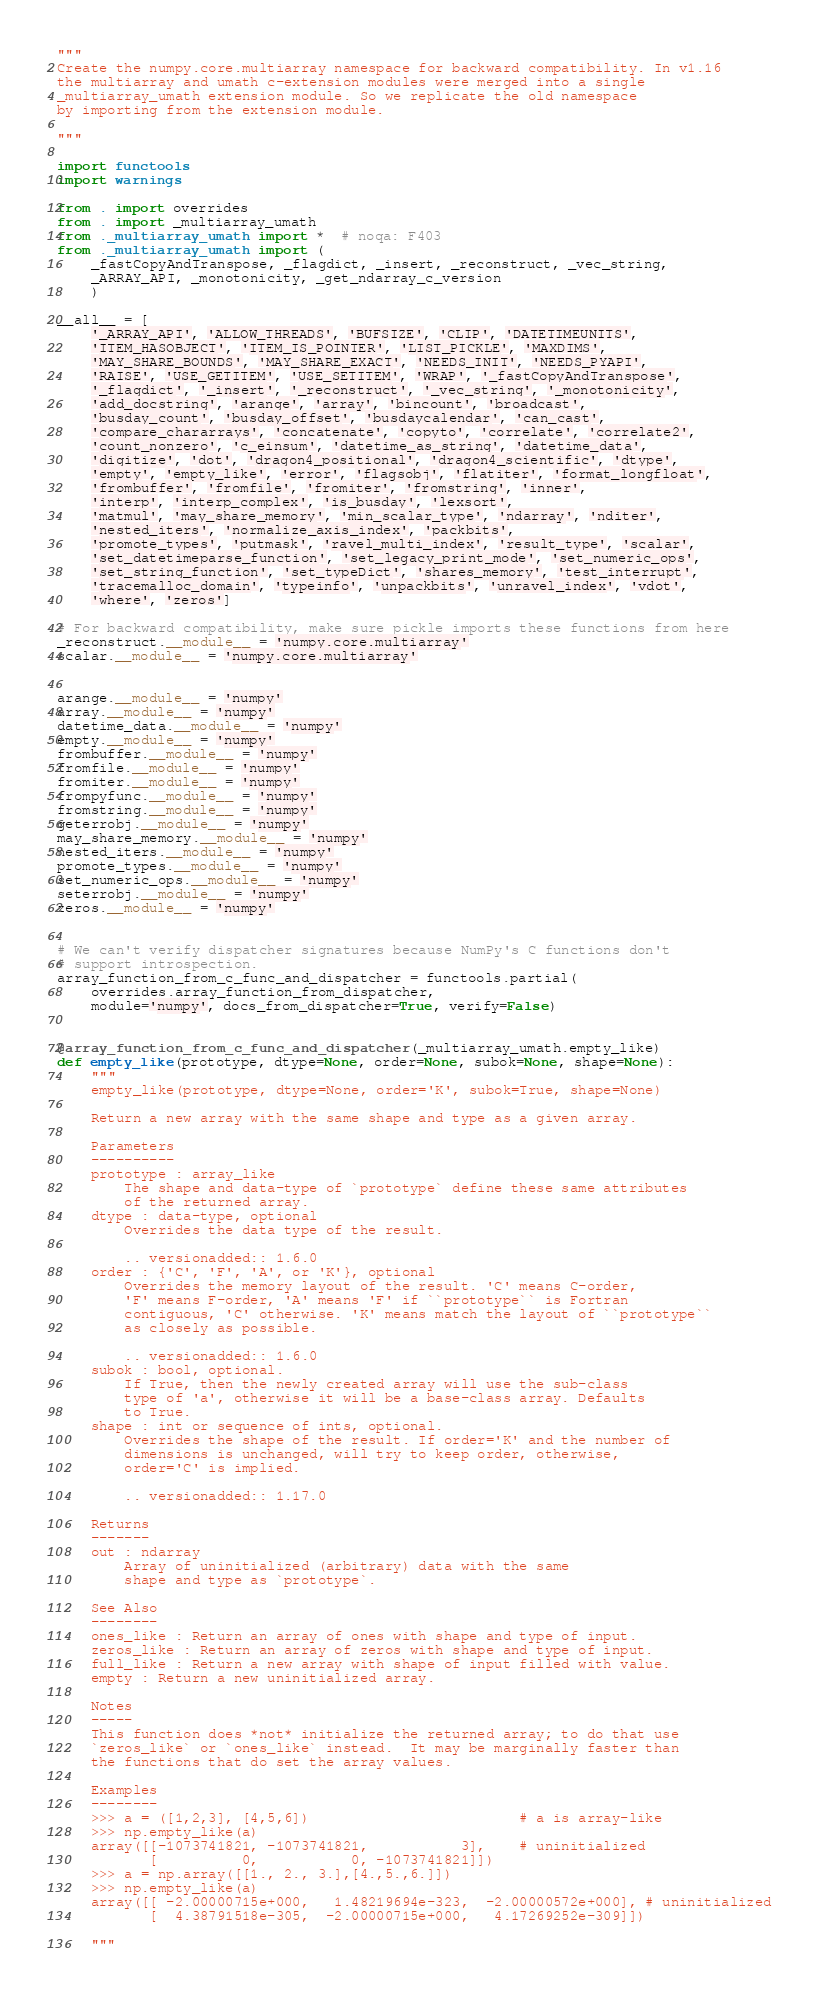Convert code to text. <code><loc_0><loc_0><loc_500><loc_500><_Python_>"""
Create the numpy.core.multiarray namespace for backward compatibility. In v1.16
the multiarray and umath c-extension modules were merged into a single
_multiarray_umath extension module. So we replicate the old namespace
by importing from the extension module.

"""

import functools
import warnings

from . import overrides
from . import _multiarray_umath
from ._multiarray_umath import *  # noqa: F403
from ._multiarray_umath import (
    _fastCopyAndTranspose, _flagdict, _insert, _reconstruct, _vec_string,
    _ARRAY_API, _monotonicity, _get_ndarray_c_version
    )

__all__ = [
    '_ARRAY_API', 'ALLOW_THREADS', 'BUFSIZE', 'CLIP', 'DATETIMEUNITS',
    'ITEM_HASOBJECT', 'ITEM_IS_POINTER', 'LIST_PICKLE', 'MAXDIMS',
    'MAY_SHARE_BOUNDS', 'MAY_SHARE_EXACT', 'NEEDS_INIT', 'NEEDS_PYAPI',
    'RAISE', 'USE_GETITEM', 'USE_SETITEM', 'WRAP', '_fastCopyAndTranspose',
    '_flagdict', '_insert', '_reconstruct', '_vec_string', '_monotonicity',
    'add_docstring', 'arange', 'array', 'bincount', 'broadcast',
    'busday_count', 'busday_offset', 'busdaycalendar', 'can_cast',
    'compare_chararrays', 'concatenate', 'copyto', 'correlate', 'correlate2',
    'count_nonzero', 'c_einsum', 'datetime_as_string', 'datetime_data',
    'digitize', 'dot', 'dragon4_positional', 'dragon4_scientific', 'dtype',
    'empty', 'empty_like', 'error', 'flagsobj', 'flatiter', 'format_longfloat',
    'frombuffer', 'fromfile', 'fromiter', 'fromstring', 'inner',
    'interp', 'interp_complex', 'is_busday', 'lexsort',
    'matmul', 'may_share_memory', 'min_scalar_type', 'ndarray', 'nditer',
    'nested_iters', 'normalize_axis_index', 'packbits',
    'promote_types', 'putmask', 'ravel_multi_index', 'result_type', 'scalar',
    'set_datetimeparse_function', 'set_legacy_print_mode', 'set_numeric_ops',
    'set_string_function', 'set_typeDict', 'shares_memory', 'test_interrupt',
    'tracemalloc_domain', 'typeinfo', 'unpackbits', 'unravel_index', 'vdot',
    'where', 'zeros']

# For backward compatibility, make sure pickle imports these functions from here
_reconstruct.__module__ = 'numpy.core.multiarray'
scalar.__module__ = 'numpy.core.multiarray'


arange.__module__ = 'numpy'
array.__module__ = 'numpy'
datetime_data.__module__ = 'numpy'
empty.__module__ = 'numpy'
frombuffer.__module__ = 'numpy'
fromfile.__module__ = 'numpy'
fromiter.__module__ = 'numpy'
frompyfunc.__module__ = 'numpy'
fromstring.__module__ = 'numpy'
geterrobj.__module__ = 'numpy'
may_share_memory.__module__ = 'numpy'
nested_iters.__module__ = 'numpy'
promote_types.__module__ = 'numpy'
set_numeric_ops.__module__ = 'numpy'
seterrobj.__module__ = 'numpy'
zeros.__module__ = 'numpy'


# We can't verify dispatcher signatures because NumPy's C functions don't
# support introspection.
array_function_from_c_func_and_dispatcher = functools.partial(
    overrides.array_function_from_dispatcher,
    module='numpy', docs_from_dispatcher=True, verify=False)


@array_function_from_c_func_and_dispatcher(_multiarray_umath.empty_like)
def empty_like(prototype, dtype=None, order=None, subok=None, shape=None):
    """
    empty_like(prototype, dtype=None, order='K', subok=True, shape=None)

    Return a new array with the same shape and type as a given array.

    Parameters
    ----------
    prototype : array_like
        The shape and data-type of `prototype` define these same attributes
        of the returned array.
    dtype : data-type, optional
        Overrides the data type of the result.

        .. versionadded:: 1.6.0
    order : {'C', 'F', 'A', or 'K'}, optional
        Overrides the memory layout of the result. 'C' means C-order,
        'F' means F-order, 'A' means 'F' if ``prototype`` is Fortran
        contiguous, 'C' otherwise. 'K' means match the layout of ``prototype``
        as closely as possible.

        .. versionadded:: 1.6.0
    subok : bool, optional.
        If True, then the newly created array will use the sub-class
        type of 'a', otherwise it will be a base-class array. Defaults
        to True.
    shape : int or sequence of ints, optional.
        Overrides the shape of the result. If order='K' and the number of
        dimensions is unchanged, will try to keep order, otherwise,
        order='C' is implied.

        .. versionadded:: 1.17.0

    Returns
    -------
    out : ndarray
        Array of uninitialized (arbitrary) data with the same
        shape and type as `prototype`.

    See Also
    --------
    ones_like : Return an array of ones with shape and type of input.
    zeros_like : Return an array of zeros with shape and type of input.
    full_like : Return a new array with shape of input filled with value.
    empty : Return a new uninitialized array.

    Notes
    -----
    This function does *not* initialize the returned array; to do that use
    `zeros_like` or `ones_like` instead.  It may be marginally faster than
    the functions that do set the array values.

    Examples
    --------
    >>> a = ([1,2,3], [4,5,6])                         # a is array-like
    >>> np.empty_like(a)
    array([[-1073741821, -1073741821,           3],    # uninitialized
           [          0,           0, -1073741821]])
    >>> a = np.array([[1., 2., 3.],[4.,5.,6.]])
    >>> np.empty_like(a)
    array([[ -2.00000715e+000,   1.48219694e-323,  -2.00000572e+000], # uninitialized
           [  4.38791518e-305,  -2.00000715e+000,   4.17269252e-309]])

    """</code> 